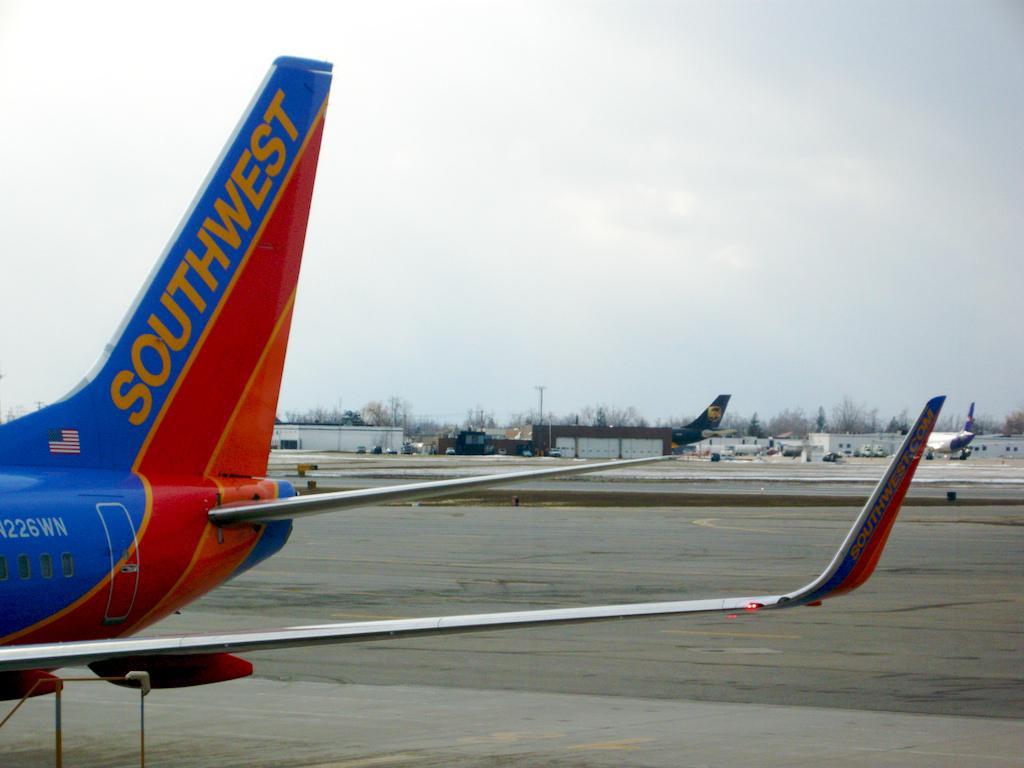What airlines is this plane flying for?
Ensure brevity in your answer.  Southwest. What type of plane is this?
Give a very brief answer. Southwest. 